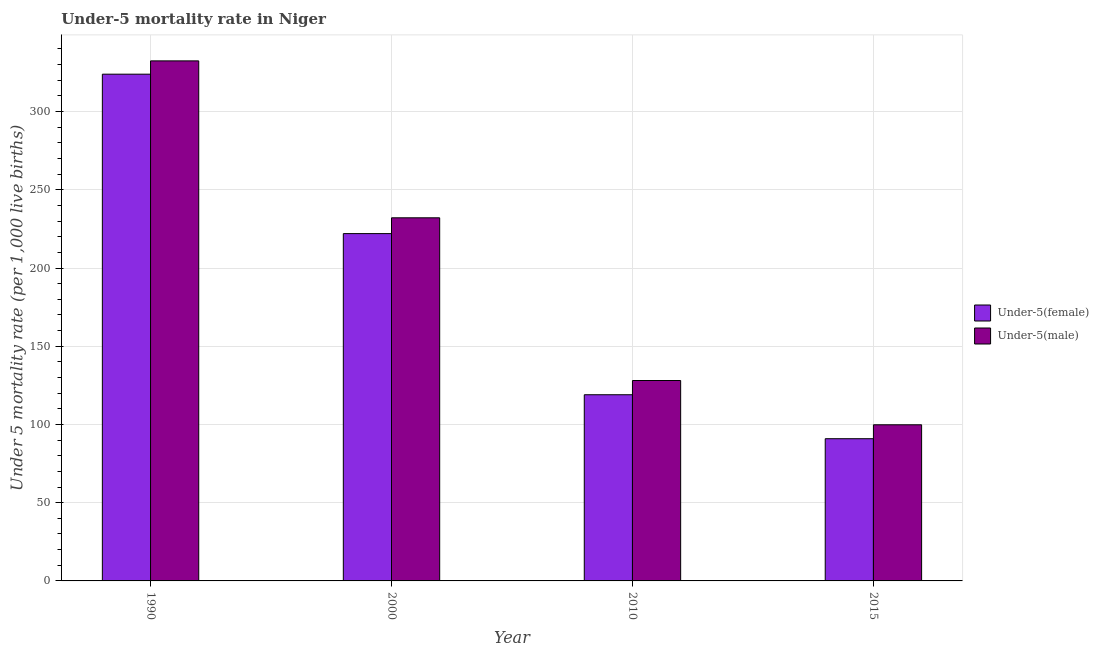How many groups of bars are there?
Your answer should be very brief. 4. Are the number of bars per tick equal to the number of legend labels?
Make the answer very short. Yes. Are the number of bars on each tick of the X-axis equal?
Give a very brief answer. Yes. How many bars are there on the 3rd tick from the left?
Keep it short and to the point. 2. How many bars are there on the 3rd tick from the right?
Your answer should be compact. 2. What is the label of the 2nd group of bars from the left?
Your answer should be compact. 2000. In how many cases, is the number of bars for a given year not equal to the number of legend labels?
Provide a short and direct response. 0. What is the under-5 male mortality rate in 2015?
Ensure brevity in your answer.  99.8. Across all years, what is the maximum under-5 male mortality rate?
Give a very brief answer. 332.4. Across all years, what is the minimum under-5 female mortality rate?
Provide a short and direct response. 90.9. In which year was the under-5 male mortality rate maximum?
Provide a short and direct response. 1990. In which year was the under-5 male mortality rate minimum?
Your answer should be compact. 2015. What is the total under-5 female mortality rate in the graph?
Keep it short and to the point. 755.8. What is the difference between the under-5 female mortality rate in 1990 and that in 2000?
Provide a short and direct response. 101.9. What is the difference between the under-5 female mortality rate in 2000 and the under-5 male mortality rate in 2010?
Your answer should be compact. 103. What is the average under-5 female mortality rate per year?
Make the answer very short. 188.95. In the year 2000, what is the difference between the under-5 female mortality rate and under-5 male mortality rate?
Keep it short and to the point. 0. In how many years, is the under-5 male mortality rate greater than 160?
Provide a short and direct response. 2. What is the ratio of the under-5 male mortality rate in 1990 to that in 2015?
Offer a terse response. 3.33. What is the difference between the highest and the second highest under-5 female mortality rate?
Give a very brief answer. 101.9. What is the difference between the highest and the lowest under-5 female mortality rate?
Ensure brevity in your answer.  233. Is the sum of the under-5 female mortality rate in 2000 and 2015 greater than the maximum under-5 male mortality rate across all years?
Make the answer very short. No. What does the 1st bar from the left in 1990 represents?
Your answer should be compact. Under-5(female). What does the 1st bar from the right in 2000 represents?
Give a very brief answer. Under-5(male). How many years are there in the graph?
Your answer should be very brief. 4. What is the difference between two consecutive major ticks on the Y-axis?
Make the answer very short. 50. How are the legend labels stacked?
Your answer should be compact. Vertical. What is the title of the graph?
Provide a succinct answer. Under-5 mortality rate in Niger. Does "Diesel" appear as one of the legend labels in the graph?
Provide a short and direct response. No. What is the label or title of the X-axis?
Offer a very short reply. Year. What is the label or title of the Y-axis?
Make the answer very short. Under 5 mortality rate (per 1,0 live births). What is the Under 5 mortality rate (per 1,000 live births) of Under-5(female) in 1990?
Offer a very short reply. 323.9. What is the Under 5 mortality rate (per 1,000 live births) in Under-5(male) in 1990?
Offer a very short reply. 332.4. What is the Under 5 mortality rate (per 1,000 live births) in Under-5(female) in 2000?
Your answer should be compact. 222. What is the Under 5 mortality rate (per 1,000 live births) of Under-5(male) in 2000?
Your answer should be compact. 232.1. What is the Under 5 mortality rate (per 1,000 live births) of Under-5(female) in 2010?
Make the answer very short. 119. What is the Under 5 mortality rate (per 1,000 live births) in Under-5(male) in 2010?
Provide a succinct answer. 128.1. What is the Under 5 mortality rate (per 1,000 live births) of Under-5(female) in 2015?
Offer a terse response. 90.9. What is the Under 5 mortality rate (per 1,000 live births) of Under-5(male) in 2015?
Provide a succinct answer. 99.8. Across all years, what is the maximum Under 5 mortality rate (per 1,000 live births) of Under-5(female)?
Your response must be concise. 323.9. Across all years, what is the maximum Under 5 mortality rate (per 1,000 live births) in Under-5(male)?
Make the answer very short. 332.4. Across all years, what is the minimum Under 5 mortality rate (per 1,000 live births) of Under-5(female)?
Provide a succinct answer. 90.9. Across all years, what is the minimum Under 5 mortality rate (per 1,000 live births) of Under-5(male)?
Keep it short and to the point. 99.8. What is the total Under 5 mortality rate (per 1,000 live births) of Under-5(female) in the graph?
Offer a very short reply. 755.8. What is the total Under 5 mortality rate (per 1,000 live births) in Under-5(male) in the graph?
Give a very brief answer. 792.4. What is the difference between the Under 5 mortality rate (per 1,000 live births) in Under-5(female) in 1990 and that in 2000?
Offer a very short reply. 101.9. What is the difference between the Under 5 mortality rate (per 1,000 live births) in Under-5(male) in 1990 and that in 2000?
Keep it short and to the point. 100.3. What is the difference between the Under 5 mortality rate (per 1,000 live births) of Under-5(female) in 1990 and that in 2010?
Provide a succinct answer. 204.9. What is the difference between the Under 5 mortality rate (per 1,000 live births) in Under-5(male) in 1990 and that in 2010?
Keep it short and to the point. 204.3. What is the difference between the Under 5 mortality rate (per 1,000 live births) of Under-5(female) in 1990 and that in 2015?
Provide a short and direct response. 233. What is the difference between the Under 5 mortality rate (per 1,000 live births) of Under-5(male) in 1990 and that in 2015?
Offer a very short reply. 232.6. What is the difference between the Under 5 mortality rate (per 1,000 live births) of Under-5(female) in 2000 and that in 2010?
Your response must be concise. 103. What is the difference between the Under 5 mortality rate (per 1,000 live births) of Under-5(male) in 2000 and that in 2010?
Give a very brief answer. 104. What is the difference between the Under 5 mortality rate (per 1,000 live births) in Under-5(female) in 2000 and that in 2015?
Make the answer very short. 131.1. What is the difference between the Under 5 mortality rate (per 1,000 live births) of Under-5(male) in 2000 and that in 2015?
Make the answer very short. 132.3. What is the difference between the Under 5 mortality rate (per 1,000 live births) in Under-5(female) in 2010 and that in 2015?
Ensure brevity in your answer.  28.1. What is the difference between the Under 5 mortality rate (per 1,000 live births) in Under-5(male) in 2010 and that in 2015?
Provide a short and direct response. 28.3. What is the difference between the Under 5 mortality rate (per 1,000 live births) in Under-5(female) in 1990 and the Under 5 mortality rate (per 1,000 live births) in Under-5(male) in 2000?
Offer a terse response. 91.8. What is the difference between the Under 5 mortality rate (per 1,000 live births) in Under-5(female) in 1990 and the Under 5 mortality rate (per 1,000 live births) in Under-5(male) in 2010?
Your response must be concise. 195.8. What is the difference between the Under 5 mortality rate (per 1,000 live births) in Under-5(female) in 1990 and the Under 5 mortality rate (per 1,000 live births) in Under-5(male) in 2015?
Keep it short and to the point. 224.1. What is the difference between the Under 5 mortality rate (per 1,000 live births) in Under-5(female) in 2000 and the Under 5 mortality rate (per 1,000 live births) in Under-5(male) in 2010?
Make the answer very short. 93.9. What is the difference between the Under 5 mortality rate (per 1,000 live births) of Under-5(female) in 2000 and the Under 5 mortality rate (per 1,000 live births) of Under-5(male) in 2015?
Give a very brief answer. 122.2. What is the difference between the Under 5 mortality rate (per 1,000 live births) in Under-5(female) in 2010 and the Under 5 mortality rate (per 1,000 live births) in Under-5(male) in 2015?
Your answer should be very brief. 19.2. What is the average Under 5 mortality rate (per 1,000 live births) of Under-5(female) per year?
Your answer should be very brief. 188.95. What is the average Under 5 mortality rate (per 1,000 live births) in Under-5(male) per year?
Make the answer very short. 198.1. In the year 2000, what is the difference between the Under 5 mortality rate (per 1,000 live births) of Under-5(female) and Under 5 mortality rate (per 1,000 live births) of Under-5(male)?
Provide a succinct answer. -10.1. In the year 2010, what is the difference between the Under 5 mortality rate (per 1,000 live births) of Under-5(female) and Under 5 mortality rate (per 1,000 live births) of Under-5(male)?
Provide a short and direct response. -9.1. In the year 2015, what is the difference between the Under 5 mortality rate (per 1,000 live births) of Under-5(female) and Under 5 mortality rate (per 1,000 live births) of Under-5(male)?
Offer a very short reply. -8.9. What is the ratio of the Under 5 mortality rate (per 1,000 live births) of Under-5(female) in 1990 to that in 2000?
Offer a very short reply. 1.46. What is the ratio of the Under 5 mortality rate (per 1,000 live births) in Under-5(male) in 1990 to that in 2000?
Give a very brief answer. 1.43. What is the ratio of the Under 5 mortality rate (per 1,000 live births) in Under-5(female) in 1990 to that in 2010?
Provide a short and direct response. 2.72. What is the ratio of the Under 5 mortality rate (per 1,000 live births) in Under-5(male) in 1990 to that in 2010?
Offer a terse response. 2.59. What is the ratio of the Under 5 mortality rate (per 1,000 live births) in Under-5(female) in 1990 to that in 2015?
Provide a short and direct response. 3.56. What is the ratio of the Under 5 mortality rate (per 1,000 live births) in Under-5(male) in 1990 to that in 2015?
Your response must be concise. 3.33. What is the ratio of the Under 5 mortality rate (per 1,000 live births) in Under-5(female) in 2000 to that in 2010?
Make the answer very short. 1.87. What is the ratio of the Under 5 mortality rate (per 1,000 live births) of Under-5(male) in 2000 to that in 2010?
Provide a succinct answer. 1.81. What is the ratio of the Under 5 mortality rate (per 1,000 live births) of Under-5(female) in 2000 to that in 2015?
Your answer should be very brief. 2.44. What is the ratio of the Under 5 mortality rate (per 1,000 live births) in Under-5(male) in 2000 to that in 2015?
Offer a terse response. 2.33. What is the ratio of the Under 5 mortality rate (per 1,000 live births) in Under-5(female) in 2010 to that in 2015?
Ensure brevity in your answer.  1.31. What is the ratio of the Under 5 mortality rate (per 1,000 live births) of Under-5(male) in 2010 to that in 2015?
Give a very brief answer. 1.28. What is the difference between the highest and the second highest Under 5 mortality rate (per 1,000 live births) of Under-5(female)?
Your answer should be compact. 101.9. What is the difference between the highest and the second highest Under 5 mortality rate (per 1,000 live births) in Under-5(male)?
Offer a terse response. 100.3. What is the difference between the highest and the lowest Under 5 mortality rate (per 1,000 live births) in Under-5(female)?
Provide a succinct answer. 233. What is the difference between the highest and the lowest Under 5 mortality rate (per 1,000 live births) of Under-5(male)?
Offer a terse response. 232.6. 